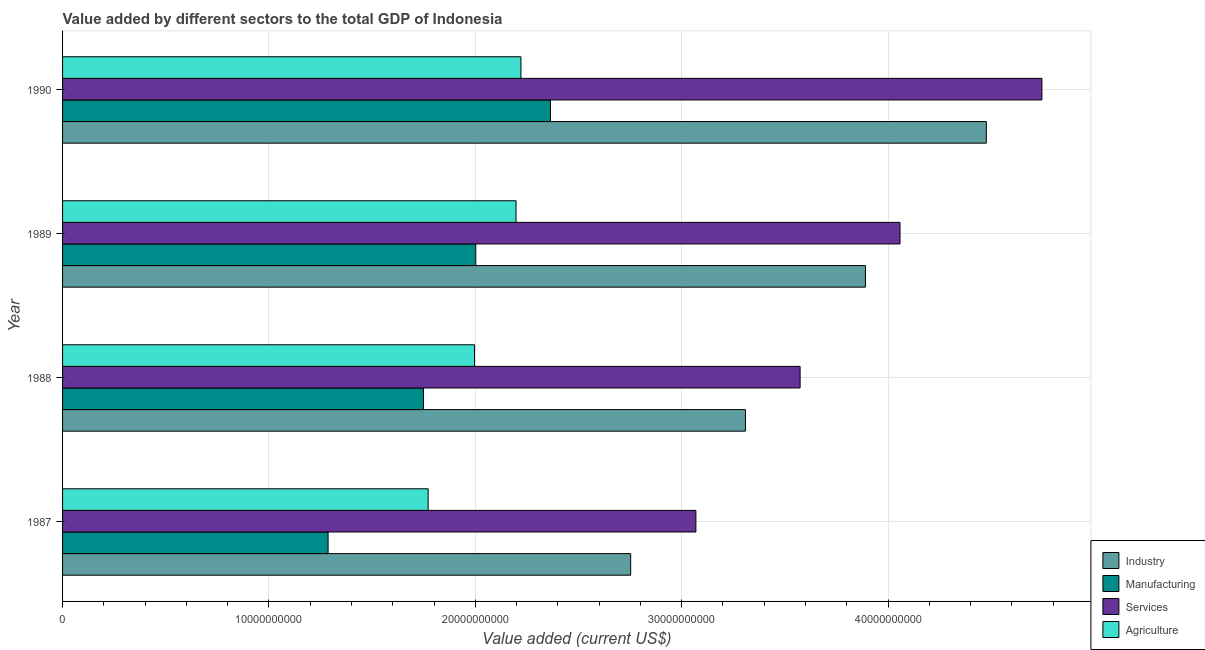How many different coloured bars are there?
Make the answer very short. 4. Are the number of bars per tick equal to the number of legend labels?
Provide a short and direct response. Yes. Are the number of bars on each tick of the Y-axis equal?
Keep it short and to the point. Yes. How many bars are there on the 1st tick from the top?
Provide a succinct answer. 4. What is the label of the 2nd group of bars from the top?
Your response must be concise. 1989. What is the value added by industrial sector in 1989?
Offer a terse response. 3.89e+1. Across all years, what is the maximum value added by agricultural sector?
Your answer should be compact. 2.22e+1. Across all years, what is the minimum value added by manufacturing sector?
Give a very brief answer. 1.29e+1. What is the total value added by manufacturing sector in the graph?
Give a very brief answer. 7.40e+1. What is the difference between the value added by industrial sector in 1988 and that in 1990?
Give a very brief answer. -1.17e+1. What is the difference between the value added by agricultural sector in 1987 and the value added by manufacturing sector in 1988?
Your answer should be very brief. 2.24e+08. What is the average value added by agricultural sector per year?
Keep it short and to the point. 2.05e+1. In the year 1987, what is the difference between the value added by services sector and value added by agricultural sector?
Offer a very short reply. 1.30e+1. What is the ratio of the value added by agricultural sector in 1987 to that in 1990?
Your answer should be compact. 0.8. Is the value added by agricultural sector in 1987 less than that in 1989?
Keep it short and to the point. Yes. What is the difference between the highest and the second highest value added by manufacturing sector?
Offer a very short reply. 3.62e+09. What is the difference between the highest and the lowest value added by agricultural sector?
Provide a short and direct response. 4.50e+09. Is the sum of the value added by industrial sector in 1987 and 1989 greater than the maximum value added by services sector across all years?
Give a very brief answer. Yes. What does the 4th bar from the top in 1989 represents?
Give a very brief answer. Industry. What does the 2nd bar from the bottom in 1987 represents?
Your answer should be very brief. Manufacturing. Is it the case that in every year, the sum of the value added by industrial sector and value added by manufacturing sector is greater than the value added by services sector?
Make the answer very short. Yes. How many bars are there?
Give a very brief answer. 16. What is the difference between two consecutive major ticks on the X-axis?
Offer a terse response. 1.00e+1. Are the values on the major ticks of X-axis written in scientific E-notation?
Keep it short and to the point. No. How many legend labels are there?
Offer a very short reply. 4. What is the title of the graph?
Your answer should be compact. Value added by different sectors to the total GDP of Indonesia. Does "Self-employed" appear as one of the legend labels in the graph?
Offer a very short reply. No. What is the label or title of the X-axis?
Provide a succinct answer. Value added (current US$). What is the label or title of the Y-axis?
Your answer should be compact. Year. What is the Value added (current US$) of Industry in 1987?
Your answer should be compact. 2.75e+1. What is the Value added (current US$) in Manufacturing in 1987?
Offer a terse response. 1.29e+1. What is the Value added (current US$) of Services in 1987?
Offer a very short reply. 3.07e+1. What is the Value added (current US$) of Agriculture in 1987?
Make the answer very short. 1.77e+1. What is the Value added (current US$) in Industry in 1988?
Give a very brief answer. 3.31e+1. What is the Value added (current US$) of Manufacturing in 1988?
Give a very brief answer. 1.75e+1. What is the Value added (current US$) in Services in 1988?
Your answer should be very brief. 3.57e+1. What is the Value added (current US$) in Agriculture in 1988?
Your answer should be very brief. 2.00e+1. What is the Value added (current US$) of Industry in 1989?
Keep it short and to the point. 3.89e+1. What is the Value added (current US$) of Manufacturing in 1989?
Your answer should be compact. 2.00e+1. What is the Value added (current US$) in Services in 1989?
Offer a terse response. 4.06e+1. What is the Value added (current US$) of Agriculture in 1989?
Ensure brevity in your answer.  2.20e+1. What is the Value added (current US$) in Industry in 1990?
Provide a succinct answer. 4.48e+1. What is the Value added (current US$) in Manufacturing in 1990?
Your response must be concise. 2.36e+1. What is the Value added (current US$) in Services in 1990?
Ensure brevity in your answer.  4.75e+1. What is the Value added (current US$) of Agriculture in 1990?
Your answer should be very brief. 2.22e+1. Across all years, what is the maximum Value added (current US$) in Industry?
Ensure brevity in your answer.  4.48e+1. Across all years, what is the maximum Value added (current US$) in Manufacturing?
Your answer should be compact. 2.36e+1. Across all years, what is the maximum Value added (current US$) of Services?
Your response must be concise. 4.75e+1. Across all years, what is the maximum Value added (current US$) of Agriculture?
Give a very brief answer. 2.22e+1. Across all years, what is the minimum Value added (current US$) of Industry?
Keep it short and to the point. 2.75e+1. Across all years, what is the minimum Value added (current US$) of Manufacturing?
Your response must be concise. 1.29e+1. Across all years, what is the minimum Value added (current US$) in Services?
Provide a succinct answer. 3.07e+1. Across all years, what is the minimum Value added (current US$) in Agriculture?
Your answer should be very brief. 1.77e+1. What is the total Value added (current US$) of Industry in the graph?
Keep it short and to the point. 1.44e+11. What is the total Value added (current US$) in Manufacturing in the graph?
Give a very brief answer. 7.40e+1. What is the total Value added (current US$) of Services in the graph?
Make the answer very short. 1.54e+11. What is the total Value added (current US$) of Agriculture in the graph?
Give a very brief answer. 8.19e+1. What is the difference between the Value added (current US$) of Industry in 1987 and that in 1988?
Your response must be concise. -5.56e+09. What is the difference between the Value added (current US$) of Manufacturing in 1987 and that in 1988?
Keep it short and to the point. -4.62e+09. What is the difference between the Value added (current US$) in Services in 1987 and that in 1988?
Provide a succinct answer. -5.05e+09. What is the difference between the Value added (current US$) in Agriculture in 1987 and that in 1988?
Provide a short and direct response. -2.25e+09. What is the difference between the Value added (current US$) of Industry in 1987 and that in 1989?
Ensure brevity in your answer.  -1.14e+1. What is the difference between the Value added (current US$) in Manufacturing in 1987 and that in 1989?
Your answer should be compact. -7.16e+09. What is the difference between the Value added (current US$) in Services in 1987 and that in 1989?
Keep it short and to the point. -9.89e+09. What is the difference between the Value added (current US$) in Agriculture in 1987 and that in 1989?
Offer a terse response. -4.26e+09. What is the difference between the Value added (current US$) in Industry in 1987 and that in 1990?
Ensure brevity in your answer.  -1.72e+1. What is the difference between the Value added (current US$) in Manufacturing in 1987 and that in 1990?
Your answer should be very brief. -1.08e+1. What is the difference between the Value added (current US$) of Services in 1987 and that in 1990?
Provide a succinct answer. -1.68e+1. What is the difference between the Value added (current US$) of Agriculture in 1987 and that in 1990?
Your answer should be very brief. -4.50e+09. What is the difference between the Value added (current US$) in Industry in 1988 and that in 1989?
Make the answer very short. -5.82e+09. What is the difference between the Value added (current US$) of Manufacturing in 1988 and that in 1989?
Offer a terse response. -2.53e+09. What is the difference between the Value added (current US$) of Services in 1988 and that in 1989?
Give a very brief answer. -4.84e+09. What is the difference between the Value added (current US$) in Agriculture in 1988 and that in 1989?
Make the answer very short. -2.01e+09. What is the difference between the Value added (current US$) in Industry in 1988 and that in 1990?
Provide a short and direct response. -1.17e+1. What is the difference between the Value added (current US$) in Manufacturing in 1988 and that in 1990?
Offer a very short reply. -6.15e+09. What is the difference between the Value added (current US$) in Services in 1988 and that in 1990?
Make the answer very short. -1.17e+1. What is the difference between the Value added (current US$) of Agriculture in 1988 and that in 1990?
Give a very brief answer. -2.25e+09. What is the difference between the Value added (current US$) of Industry in 1989 and that in 1990?
Your response must be concise. -5.86e+09. What is the difference between the Value added (current US$) of Manufacturing in 1989 and that in 1990?
Give a very brief answer. -3.62e+09. What is the difference between the Value added (current US$) in Services in 1989 and that in 1990?
Offer a very short reply. -6.88e+09. What is the difference between the Value added (current US$) in Agriculture in 1989 and that in 1990?
Your response must be concise. -2.37e+08. What is the difference between the Value added (current US$) in Industry in 1987 and the Value added (current US$) in Manufacturing in 1988?
Provide a short and direct response. 1.00e+1. What is the difference between the Value added (current US$) in Industry in 1987 and the Value added (current US$) in Services in 1988?
Keep it short and to the point. -8.21e+09. What is the difference between the Value added (current US$) in Industry in 1987 and the Value added (current US$) in Agriculture in 1988?
Give a very brief answer. 7.57e+09. What is the difference between the Value added (current US$) in Manufacturing in 1987 and the Value added (current US$) in Services in 1988?
Your answer should be compact. -2.29e+1. What is the difference between the Value added (current US$) of Manufacturing in 1987 and the Value added (current US$) of Agriculture in 1988?
Make the answer very short. -7.10e+09. What is the difference between the Value added (current US$) in Services in 1987 and the Value added (current US$) in Agriculture in 1988?
Provide a succinct answer. 1.07e+1. What is the difference between the Value added (current US$) in Industry in 1987 and the Value added (current US$) in Manufacturing in 1989?
Keep it short and to the point. 7.51e+09. What is the difference between the Value added (current US$) of Industry in 1987 and the Value added (current US$) of Services in 1989?
Make the answer very short. -1.31e+1. What is the difference between the Value added (current US$) of Industry in 1987 and the Value added (current US$) of Agriculture in 1989?
Provide a succinct answer. 5.55e+09. What is the difference between the Value added (current US$) in Manufacturing in 1987 and the Value added (current US$) in Services in 1989?
Provide a succinct answer. -2.77e+1. What is the difference between the Value added (current US$) of Manufacturing in 1987 and the Value added (current US$) of Agriculture in 1989?
Your answer should be very brief. -9.11e+09. What is the difference between the Value added (current US$) in Services in 1987 and the Value added (current US$) in Agriculture in 1989?
Give a very brief answer. 8.71e+09. What is the difference between the Value added (current US$) in Industry in 1987 and the Value added (current US$) in Manufacturing in 1990?
Give a very brief answer. 3.88e+09. What is the difference between the Value added (current US$) in Industry in 1987 and the Value added (current US$) in Services in 1990?
Give a very brief answer. -1.99e+1. What is the difference between the Value added (current US$) in Industry in 1987 and the Value added (current US$) in Agriculture in 1990?
Offer a terse response. 5.32e+09. What is the difference between the Value added (current US$) of Manufacturing in 1987 and the Value added (current US$) of Services in 1990?
Ensure brevity in your answer.  -3.46e+1. What is the difference between the Value added (current US$) of Manufacturing in 1987 and the Value added (current US$) of Agriculture in 1990?
Your answer should be compact. -9.34e+09. What is the difference between the Value added (current US$) in Services in 1987 and the Value added (current US$) in Agriculture in 1990?
Offer a terse response. 8.48e+09. What is the difference between the Value added (current US$) in Industry in 1988 and the Value added (current US$) in Manufacturing in 1989?
Provide a succinct answer. 1.31e+1. What is the difference between the Value added (current US$) of Industry in 1988 and the Value added (current US$) of Services in 1989?
Provide a short and direct response. -7.49e+09. What is the difference between the Value added (current US$) in Industry in 1988 and the Value added (current US$) in Agriculture in 1989?
Make the answer very short. 1.11e+1. What is the difference between the Value added (current US$) in Manufacturing in 1988 and the Value added (current US$) in Services in 1989?
Ensure brevity in your answer.  -2.31e+1. What is the difference between the Value added (current US$) of Manufacturing in 1988 and the Value added (current US$) of Agriculture in 1989?
Offer a very short reply. -4.48e+09. What is the difference between the Value added (current US$) of Services in 1988 and the Value added (current US$) of Agriculture in 1989?
Make the answer very short. 1.38e+1. What is the difference between the Value added (current US$) in Industry in 1988 and the Value added (current US$) in Manufacturing in 1990?
Make the answer very short. 9.44e+09. What is the difference between the Value added (current US$) of Industry in 1988 and the Value added (current US$) of Services in 1990?
Ensure brevity in your answer.  -1.44e+1. What is the difference between the Value added (current US$) of Industry in 1988 and the Value added (current US$) of Agriculture in 1990?
Your response must be concise. 1.09e+1. What is the difference between the Value added (current US$) of Manufacturing in 1988 and the Value added (current US$) of Services in 1990?
Make the answer very short. -3.00e+1. What is the difference between the Value added (current US$) of Manufacturing in 1988 and the Value added (current US$) of Agriculture in 1990?
Give a very brief answer. -4.72e+09. What is the difference between the Value added (current US$) of Services in 1988 and the Value added (current US$) of Agriculture in 1990?
Ensure brevity in your answer.  1.35e+1. What is the difference between the Value added (current US$) in Industry in 1989 and the Value added (current US$) in Manufacturing in 1990?
Provide a short and direct response. 1.53e+1. What is the difference between the Value added (current US$) of Industry in 1989 and the Value added (current US$) of Services in 1990?
Your response must be concise. -8.55e+09. What is the difference between the Value added (current US$) of Industry in 1989 and the Value added (current US$) of Agriculture in 1990?
Your answer should be compact. 1.67e+1. What is the difference between the Value added (current US$) of Manufacturing in 1989 and the Value added (current US$) of Services in 1990?
Provide a short and direct response. -2.74e+1. What is the difference between the Value added (current US$) of Manufacturing in 1989 and the Value added (current US$) of Agriculture in 1990?
Your answer should be compact. -2.19e+09. What is the difference between the Value added (current US$) of Services in 1989 and the Value added (current US$) of Agriculture in 1990?
Offer a terse response. 1.84e+1. What is the average Value added (current US$) of Industry per year?
Your answer should be compact. 3.61e+1. What is the average Value added (current US$) in Manufacturing per year?
Make the answer very short. 1.85e+1. What is the average Value added (current US$) in Services per year?
Provide a short and direct response. 3.86e+1. What is the average Value added (current US$) in Agriculture per year?
Offer a terse response. 2.05e+1. In the year 1987, what is the difference between the Value added (current US$) in Industry and Value added (current US$) in Manufacturing?
Your answer should be compact. 1.47e+1. In the year 1987, what is the difference between the Value added (current US$) in Industry and Value added (current US$) in Services?
Give a very brief answer. -3.16e+09. In the year 1987, what is the difference between the Value added (current US$) in Industry and Value added (current US$) in Agriculture?
Keep it short and to the point. 9.81e+09. In the year 1987, what is the difference between the Value added (current US$) in Manufacturing and Value added (current US$) in Services?
Offer a very short reply. -1.78e+1. In the year 1987, what is the difference between the Value added (current US$) in Manufacturing and Value added (current US$) in Agriculture?
Your answer should be very brief. -4.85e+09. In the year 1987, what is the difference between the Value added (current US$) of Services and Value added (current US$) of Agriculture?
Provide a succinct answer. 1.30e+1. In the year 1988, what is the difference between the Value added (current US$) in Industry and Value added (current US$) in Manufacturing?
Provide a short and direct response. 1.56e+1. In the year 1988, what is the difference between the Value added (current US$) in Industry and Value added (current US$) in Services?
Keep it short and to the point. -2.65e+09. In the year 1988, what is the difference between the Value added (current US$) of Industry and Value added (current US$) of Agriculture?
Your response must be concise. 1.31e+1. In the year 1988, what is the difference between the Value added (current US$) of Manufacturing and Value added (current US$) of Services?
Keep it short and to the point. -1.82e+1. In the year 1988, what is the difference between the Value added (current US$) in Manufacturing and Value added (current US$) in Agriculture?
Your answer should be very brief. -2.47e+09. In the year 1988, what is the difference between the Value added (current US$) of Services and Value added (current US$) of Agriculture?
Offer a very short reply. 1.58e+1. In the year 1989, what is the difference between the Value added (current US$) in Industry and Value added (current US$) in Manufacturing?
Your answer should be compact. 1.89e+1. In the year 1989, what is the difference between the Value added (current US$) of Industry and Value added (current US$) of Services?
Offer a terse response. -1.68e+09. In the year 1989, what is the difference between the Value added (current US$) of Industry and Value added (current US$) of Agriculture?
Provide a succinct answer. 1.69e+1. In the year 1989, what is the difference between the Value added (current US$) of Manufacturing and Value added (current US$) of Services?
Provide a succinct answer. -2.06e+1. In the year 1989, what is the difference between the Value added (current US$) in Manufacturing and Value added (current US$) in Agriculture?
Provide a short and direct response. -1.95e+09. In the year 1989, what is the difference between the Value added (current US$) of Services and Value added (current US$) of Agriculture?
Your answer should be compact. 1.86e+1. In the year 1990, what is the difference between the Value added (current US$) of Industry and Value added (current US$) of Manufacturing?
Ensure brevity in your answer.  2.11e+1. In the year 1990, what is the difference between the Value added (current US$) of Industry and Value added (current US$) of Services?
Ensure brevity in your answer.  -2.69e+09. In the year 1990, what is the difference between the Value added (current US$) of Industry and Value added (current US$) of Agriculture?
Your answer should be very brief. 2.26e+1. In the year 1990, what is the difference between the Value added (current US$) in Manufacturing and Value added (current US$) in Services?
Offer a very short reply. -2.38e+1. In the year 1990, what is the difference between the Value added (current US$) of Manufacturing and Value added (current US$) of Agriculture?
Your answer should be very brief. 1.43e+09. In the year 1990, what is the difference between the Value added (current US$) of Services and Value added (current US$) of Agriculture?
Make the answer very short. 2.52e+1. What is the ratio of the Value added (current US$) in Industry in 1987 to that in 1988?
Give a very brief answer. 0.83. What is the ratio of the Value added (current US$) in Manufacturing in 1987 to that in 1988?
Your answer should be compact. 0.74. What is the ratio of the Value added (current US$) in Services in 1987 to that in 1988?
Your answer should be very brief. 0.86. What is the ratio of the Value added (current US$) of Agriculture in 1987 to that in 1988?
Make the answer very short. 0.89. What is the ratio of the Value added (current US$) in Industry in 1987 to that in 1989?
Keep it short and to the point. 0.71. What is the ratio of the Value added (current US$) in Manufacturing in 1987 to that in 1989?
Make the answer very short. 0.64. What is the ratio of the Value added (current US$) in Services in 1987 to that in 1989?
Keep it short and to the point. 0.76. What is the ratio of the Value added (current US$) of Agriculture in 1987 to that in 1989?
Keep it short and to the point. 0.81. What is the ratio of the Value added (current US$) in Industry in 1987 to that in 1990?
Give a very brief answer. 0.61. What is the ratio of the Value added (current US$) in Manufacturing in 1987 to that in 1990?
Keep it short and to the point. 0.54. What is the ratio of the Value added (current US$) of Services in 1987 to that in 1990?
Your answer should be compact. 0.65. What is the ratio of the Value added (current US$) of Agriculture in 1987 to that in 1990?
Offer a very short reply. 0.8. What is the ratio of the Value added (current US$) in Industry in 1988 to that in 1989?
Give a very brief answer. 0.85. What is the ratio of the Value added (current US$) in Manufacturing in 1988 to that in 1989?
Offer a very short reply. 0.87. What is the ratio of the Value added (current US$) in Services in 1988 to that in 1989?
Offer a terse response. 0.88. What is the ratio of the Value added (current US$) in Agriculture in 1988 to that in 1989?
Offer a terse response. 0.91. What is the ratio of the Value added (current US$) of Industry in 1988 to that in 1990?
Ensure brevity in your answer.  0.74. What is the ratio of the Value added (current US$) of Manufacturing in 1988 to that in 1990?
Keep it short and to the point. 0.74. What is the ratio of the Value added (current US$) of Services in 1988 to that in 1990?
Offer a terse response. 0.75. What is the ratio of the Value added (current US$) in Agriculture in 1988 to that in 1990?
Make the answer very short. 0.9. What is the ratio of the Value added (current US$) in Industry in 1989 to that in 1990?
Make the answer very short. 0.87. What is the ratio of the Value added (current US$) in Manufacturing in 1989 to that in 1990?
Offer a very short reply. 0.85. What is the ratio of the Value added (current US$) of Services in 1989 to that in 1990?
Your response must be concise. 0.86. What is the ratio of the Value added (current US$) in Agriculture in 1989 to that in 1990?
Provide a succinct answer. 0.99. What is the difference between the highest and the second highest Value added (current US$) of Industry?
Offer a terse response. 5.86e+09. What is the difference between the highest and the second highest Value added (current US$) in Manufacturing?
Your answer should be compact. 3.62e+09. What is the difference between the highest and the second highest Value added (current US$) in Services?
Your answer should be very brief. 6.88e+09. What is the difference between the highest and the second highest Value added (current US$) in Agriculture?
Offer a very short reply. 2.37e+08. What is the difference between the highest and the lowest Value added (current US$) of Industry?
Your answer should be very brief. 1.72e+1. What is the difference between the highest and the lowest Value added (current US$) of Manufacturing?
Make the answer very short. 1.08e+1. What is the difference between the highest and the lowest Value added (current US$) in Services?
Offer a terse response. 1.68e+1. What is the difference between the highest and the lowest Value added (current US$) in Agriculture?
Offer a terse response. 4.50e+09. 